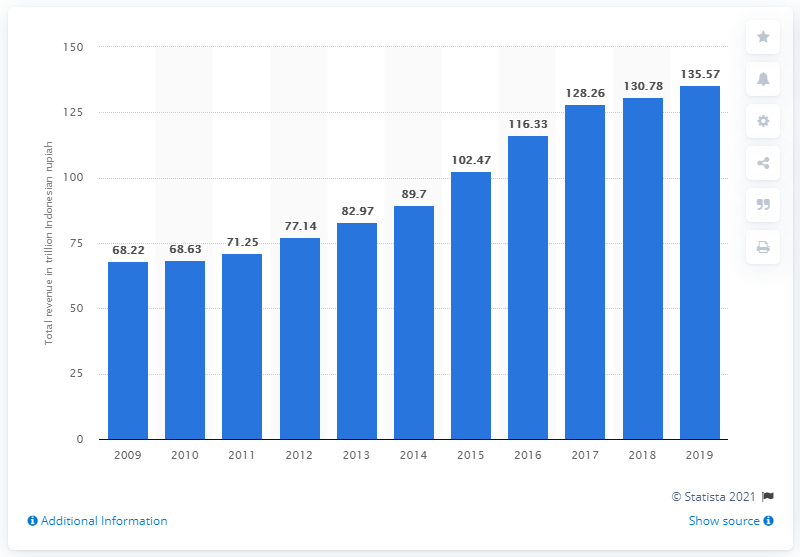List a handful of essential elements in this visual. In 2019, the total revenue of PT Telkom Indonesia was Rp135.57 trillion. 